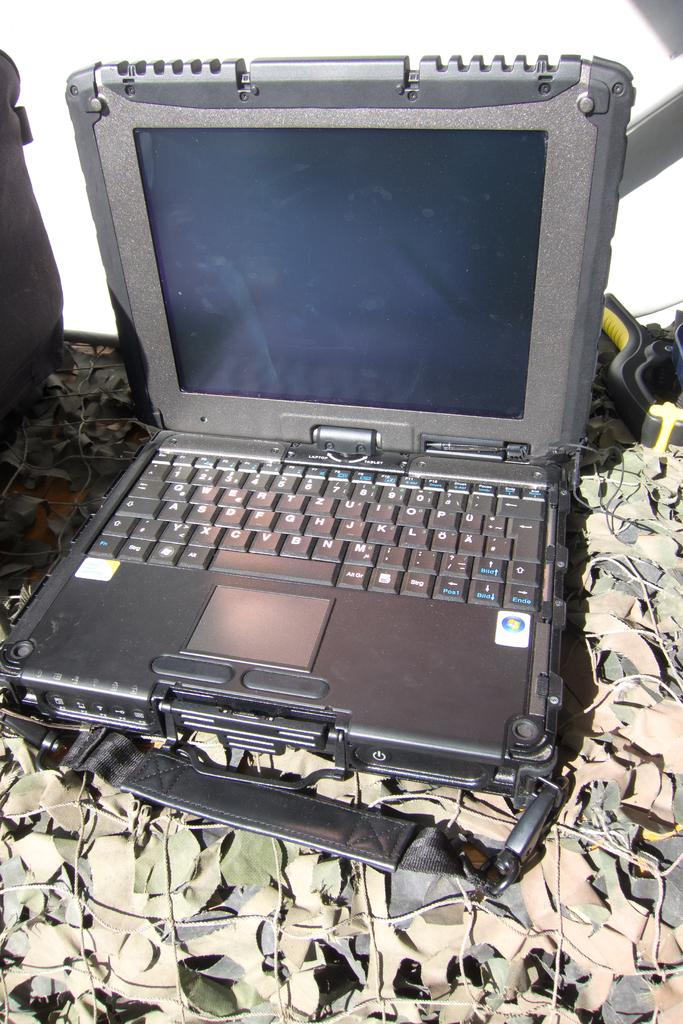What electronic device is visible in the image? There is a laptop in the image. What can be seen on either side of the laptop? There are items on both sides of the laptop. What color is the background of the image? The background of the image is white. Where is the tub located in the image? There is no tub present in the image. 